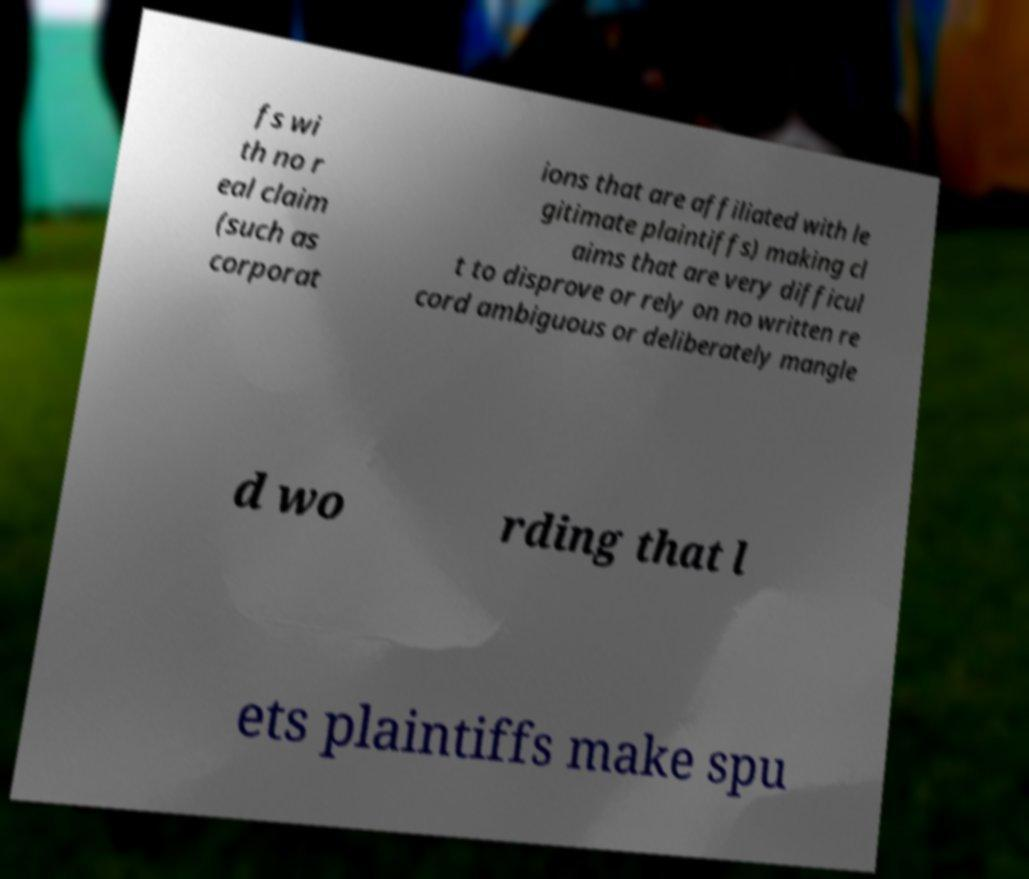Could you extract and type out the text from this image? fs wi th no r eal claim (such as corporat ions that are affiliated with le gitimate plaintiffs) making cl aims that are very difficul t to disprove or rely on no written re cord ambiguous or deliberately mangle d wo rding that l ets plaintiffs make spu 